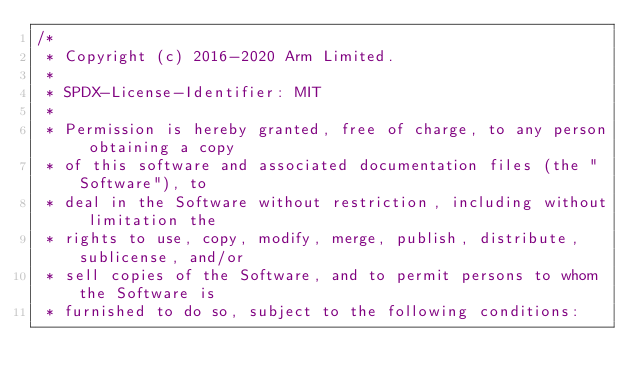Convert code to text. <code><loc_0><loc_0><loc_500><loc_500><_C++_>/*
 * Copyright (c) 2016-2020 Arm Limited.
 *
 * SPDX-License-Identifier: MIT
 *
 * Permission is hereby granted, free of charge, to any person obtaining a copy
 * of this software and associated documentation files (the "Software"), to
 * deal in the Software without restriction, including without limitation the
 * rights to use, copy, modify, merge, publish, distribute, sublicense, and/or
 * sell copies of the Software, and to permit persons to whom the Software is
 * furnished to do so, subject to the following conditions:</code> 